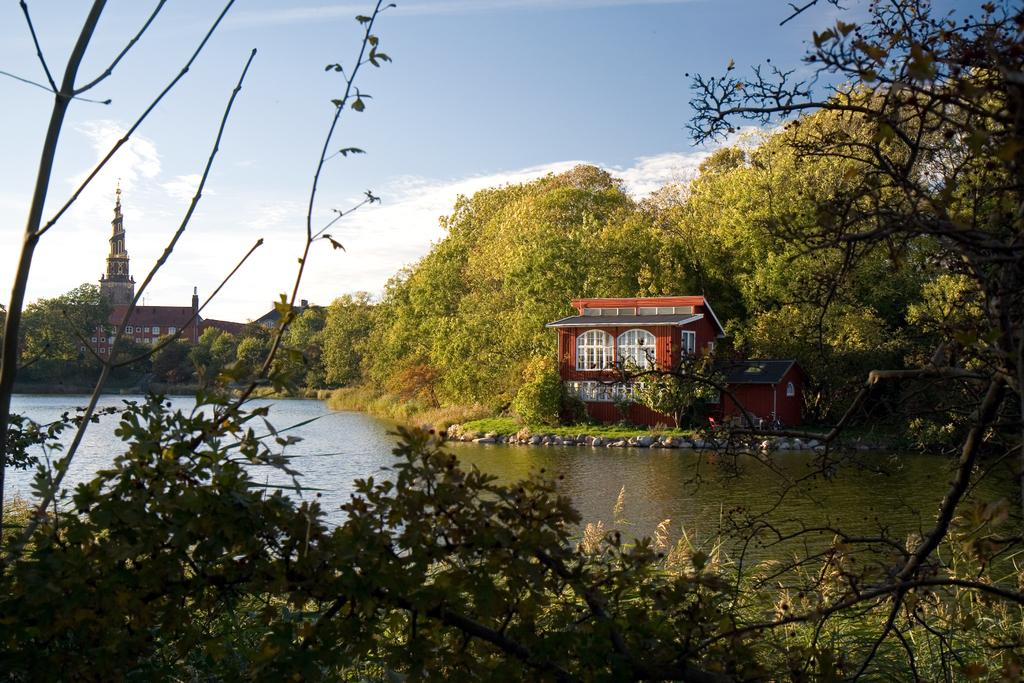What type of structures can be seen in the image? There are buildings in the image. What natural elements are present in the image? There are many trees and water visible in the image. What type of ground surface can be seen in the image? There are stones in the image. What is visible in the background of the image? The sky is visible in the image, and there are clouds in the sky. What type of rings can be seen on the trees in the image? There are no rings visible on the trees in the image. What type of drug is being used by the people in the image? There are no people or drugs present in the image. 